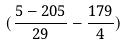<formula> <loc_0><loc_0><loc_500><loc_500>( \frac { 5 - 2 0 5 } { 2 9 } - \frac { 1 7 9 } { 4 } )</formula> 